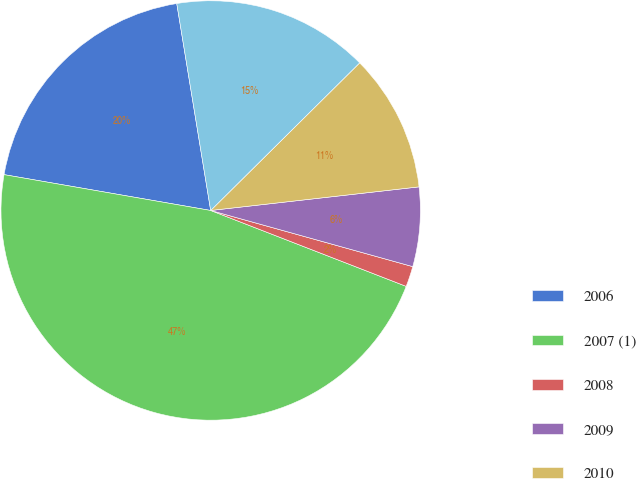Convert chart to OTSL. <chart><loc_0><loc_0><loc_500><loc_500><pie_chart><fcel>2006<fcel>2007 (1)<fcel>2008<fcel>2009<fcel>2010<fcel>Thereafter<nl><fcel>19.68%<fcel>46.84%<fcel>1.58%<fcel>6.11%<fcel>10.63%<fcel>15.16%<nl></chart> 